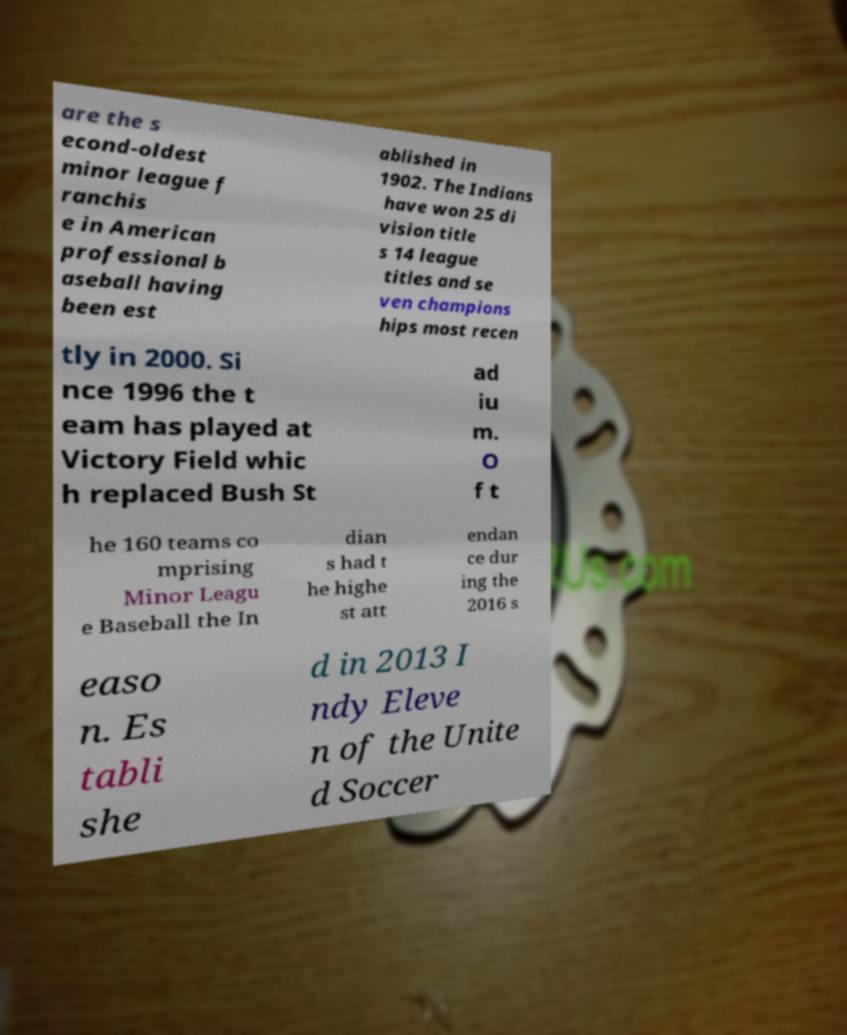Please read and relay the text visible in this image. What does it say? are the s econd-oldest minor league f ranchis e in American professional b aseball having been est ablished in 1902. The Indians have won 25 di vision title s 14 league titles and se ven champions hips most recen tly in 2000. Si nce 1996 the t eam has played at Victory Field whic h replaced Bush St ad iu m. O f t he 160 teams co mprising Minor Leagu e Baseball the In dian s had t he highe st att endan ce dur ing the 2016 s easo n. Es tabli she d in 2013 I ndy Eleve n of the Unite d Soccer 